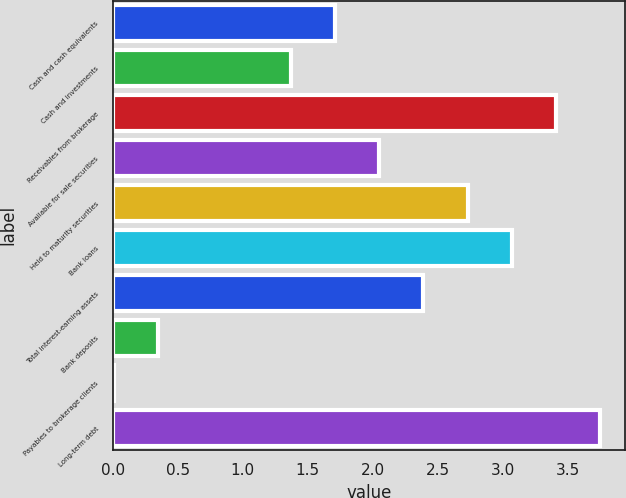Convert chart. <chart><loc_0><loc_0><loc_500><loc_500><bar_chart><fcel>Cash and cash equivalents<fcel>Cash and investments<fcel>Receivables from brokerage<fcel>Available for sale securities<fcel>Held to maturity securities<fcel>Bank loans<fcel>Total interest-earning assets<fcel>Bank deposits<fcel>Payables to brokerage clients<fcel>Long-term debt<nl><fcel>1.71<fcel>1.37<fcel>3.41<fcel>2.05<fcel>2.73<fcel>3.07<fcel>2.39<fcel>0.35<fcel>0.01<fcel>3.75<nl></chart> 